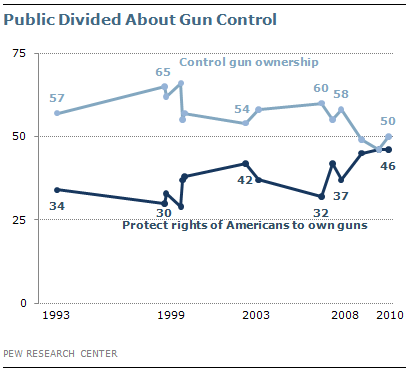Outline some significant characteristics in this image. In 2008, the two lines crossed. The lowest value of control over gun ownership is 50%. 